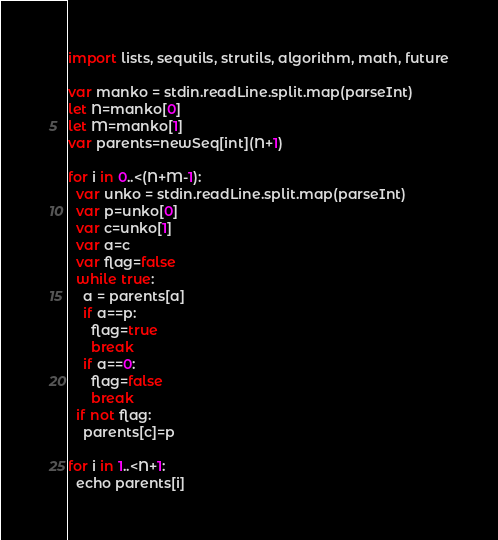Convert code to text. <code><loc_0><loc_0><loc_500><loc_500><_Nim_>import lists, sequtils, strutils, algorithm, math, future

var manko = stdin.readLine.split.map(parseInt)
let N=manko[0]
let M=manko[1]
var parents=newSeq[int](N+1)

for i in 0..<(N+M-1):
  var unko = stdin.readLine.split.map(parseInt)
  var p=unko[0]
  var c=unko[1]
  var a=c
  var flag=false
  while true:
    a = parents[a]
    if a==p:
      flag=true
      break
    if a==0:
      flag=false
      break
  if not flag:
    parents[c]=p

for i in 1..<N+1:
  echo parents[i]</code> 